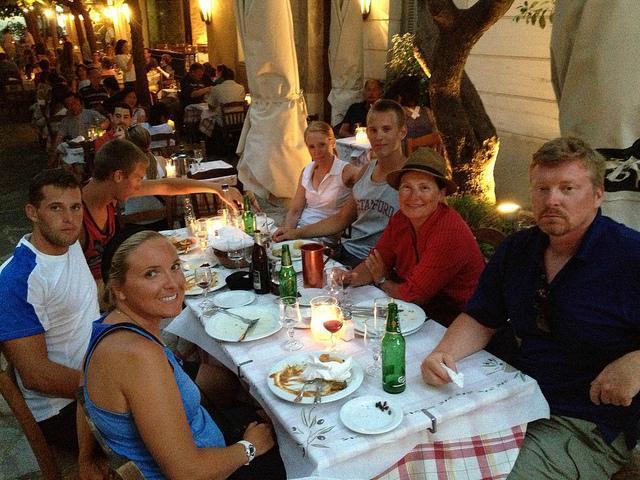How many people can you see?
Give a very brief answer. 9. How many dining tables are in the photo?
Give a very brief answer. 2. How many bears are there?
Give a very brief answer. 0. 